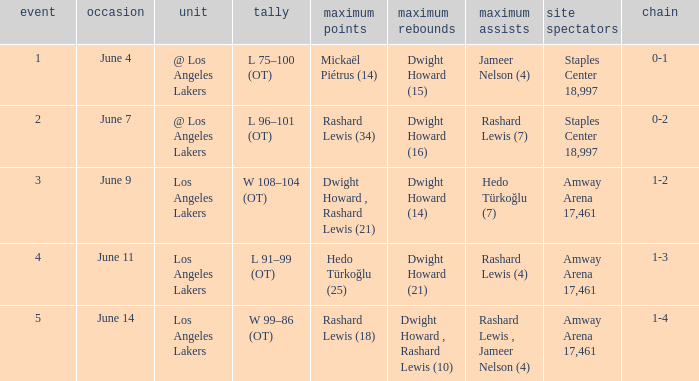What is the peak points, when top rebounds is "dwight howard (16)"? Rashard Lewis (34). 